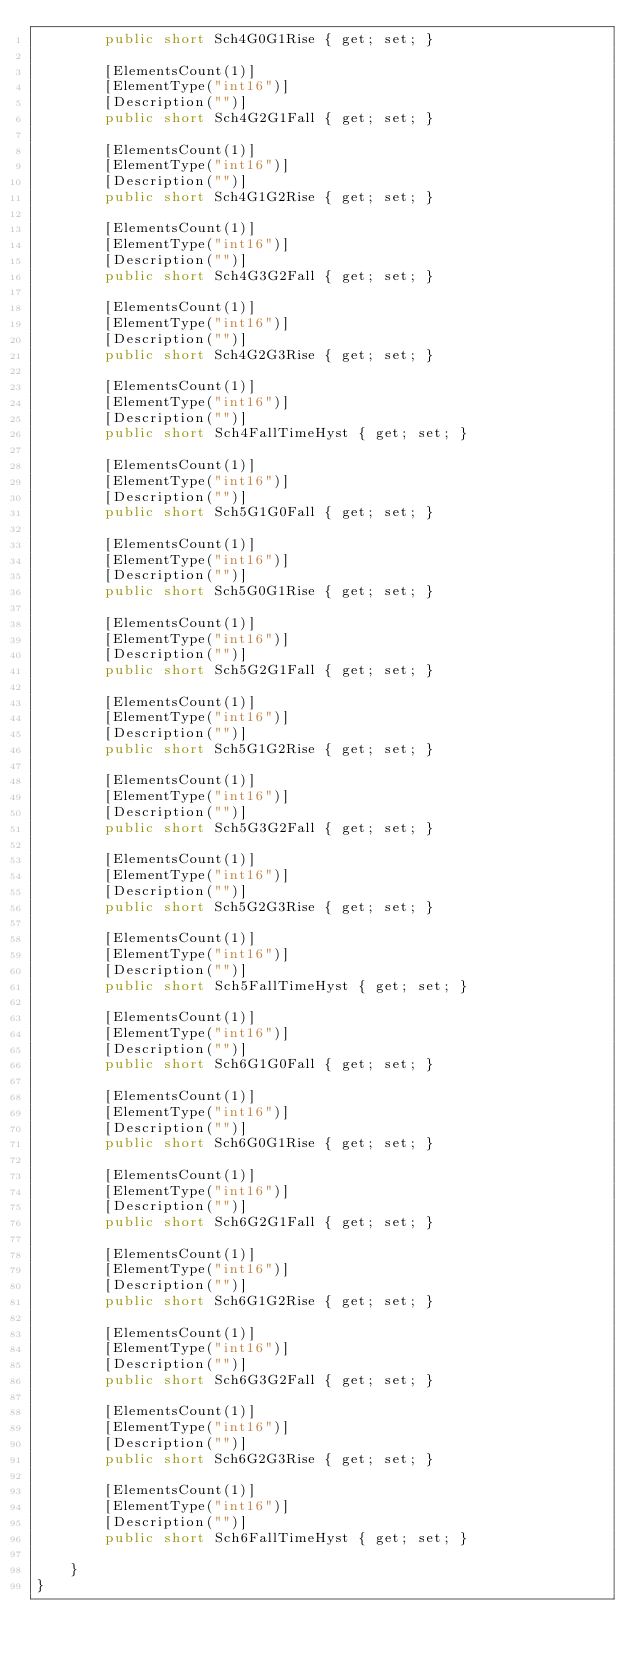<code> <loc_0><loc_0><loc_500><loc_500><_C#_>        public short Sch4G0G1Rise { get; set; }
        
        [ElementsCount(1)]
        [ElementType("int16")]
        [Description("")]
        public short Sch4G2G1Fall { get; set; }
        
        [ElementsCount(1)]
        [ElementType("int16")]
        [Description("")]
        public short Sch4G1G2Rise { get; set; }
        
        [ElementsCount(1)]
        [ElementType("int16")]
        [Description("")]
        public short Sch4G3G2Fall { get; set; }
        
        [ElementsCount(1)]
        [ElementType("int16")]
        [Description("")]
        public short Sch4G2G3Rise { get; set; }
        
        [ElementsCount(1)]
        [ElementType("int16")]
        [Description("")]
        public short Sch4FallTimeHyst { get; set; }
        
        [ElementsCount(1)]
        [ElementType("int16")]
        [Description("")]
        public short Sch5G1G0Fall { get; set; }
        
        [ElementsCount(1)]
        [ElementType("int16")]
        [Description("")]
        public short Sch5G0G1Rise { get; set; }
        
        [ElementsCount(1)]
        [ElementType("int16")]
        [Description("")]
        public short Sch5G2G1Fall { get; set; }
        
        [ElementsCount(1)]
        [ElementType("int16")]
        [Description("")]
        public short Sch5G1G2Rise { get; set; }
        
        [ElementsCount(1)]
        [ElementType("int16")]
        [Description("")]
        public short Sch5G3G2Fall { get; set; }
        
        [ElementsCount(1)]
        [ElementType("int16")]
        [Description("")]
        public short Sch5G2G3Rise { get; set; }
        
        [ElementsCount(1)]
        [ElementType("int16")]
        [Description("")]
        public short Sch5FallTimeHyst { get; set; }
        
        [ElementsCount(1)]
        [ElementType("int16")]
        [Description("")]
        public short Sch6G1G0Fall { get; set; }
        
        [ElementsCount(1)]
        [ElementType("int16")]
        [Description("")]
        public short Sch6G0G1Rise { get; set; }
        
        [ElementsCount(1)]
        [ElementType("int16")]
        [Description("")]
        public short Sch6G2G1Fall { get; set; }
        
        [ElementsCount(1)]
        [ElementType("int16")]
        [Description("")]
        public short Sch6G1G2Rise { get; set; }
        
        [ElementsCount(1)]
        [ElementType("int16")]
        [Description("")]
        public short Sch6G3G2Fall { get; set; }
        
        [ElementsCount(1)]
        [ElementType("int16")]
        [Description("")]
        public short Sch6G2G3Rise { get; set; }
        
        [ElementsCount(1)]
        [ElementType("int16")]
        [Description("")]
        public short Sch6FallTimeHyst { get; set; }
        
    }
}
</code> 